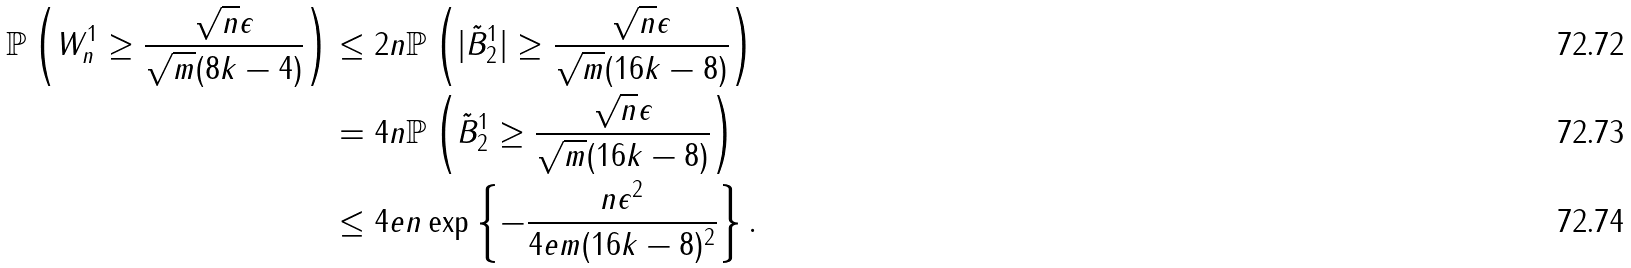<formula> <loc_0><loc_0><loc_500><loc_500>\mathbb { P } \left ( W _ { n } ^ { 1 } \geq \frac { \sqrt { n } \epsilon } { \sqrt { m } ( 8 k - 4 ) } \right ) & \leq 2 n \mathbb { P } \left ( | \tilde { B } _ { 2 } ^ { 1 } | \geq \frac { \sqrt { n } \epsilon } { \sqrt { m } ( 1 6 k - 8 ) } \right ) \\ & = 4 n \mathbb { P } \left ( \tilde { B } _ { 2 } ^ { 1 } \geq \frac { \sqrt { n } \epsilon } { \sqrt { m } ( 1 6 k - 8 ) } \right ) \\ & \leq 4 e n \exp \left \{ - \frac { n \epsilon ^ { 2 } } { 4 e m ( 1 6 k - 8 ) ^ { 2 } } \right \} .</formula> 